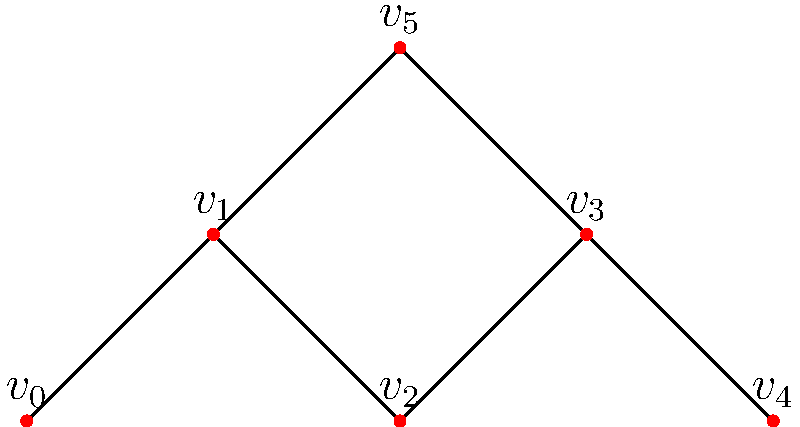In the music collaboration network represented by the undirected graph above, where each vertex represents an artist and each edge represents a collaboration, what is the minimum number of collaborations (edges) that need to be added to make the graph 2-connected? To determine the minimum number of collaborations needed to make the graph 2-connected, we need to follow these steps:

1. Understand 2-connectivity: A graph is 2-connected if it remains connected after removing any single vertex.

2. Identify the current connectivity:
   - The graph is currently 1-connected (connected but not 2-connected).
   - Removing vertex $v_2$ or $v_3$ would disconnect the graph.

3. Identify the articulation points:
   - $v_2$ and $v_3$ are articulation points (their removal disconnects the graph).

4. Determine the minimum edges needed:
   - To make the graph 2-connected, we need to add edges that bypass these articulation points.
   - The minimum number of edges to add is 1.

5. Possible edge to add:
   - Adding an edge between $v_1$ and $v_4$ would make the graph 2-connected.
   - This new edge provides an alternate path between all vertices, bypassing both $v_2$ and $v_3$.

6. Verify:
   - After adding this edge, removing any single vertex would not disconnect the graph.

Therefore, the minimum number of collaborations (edges) that need to be added to make the graph 2-connected is 1.
Answer: 1 